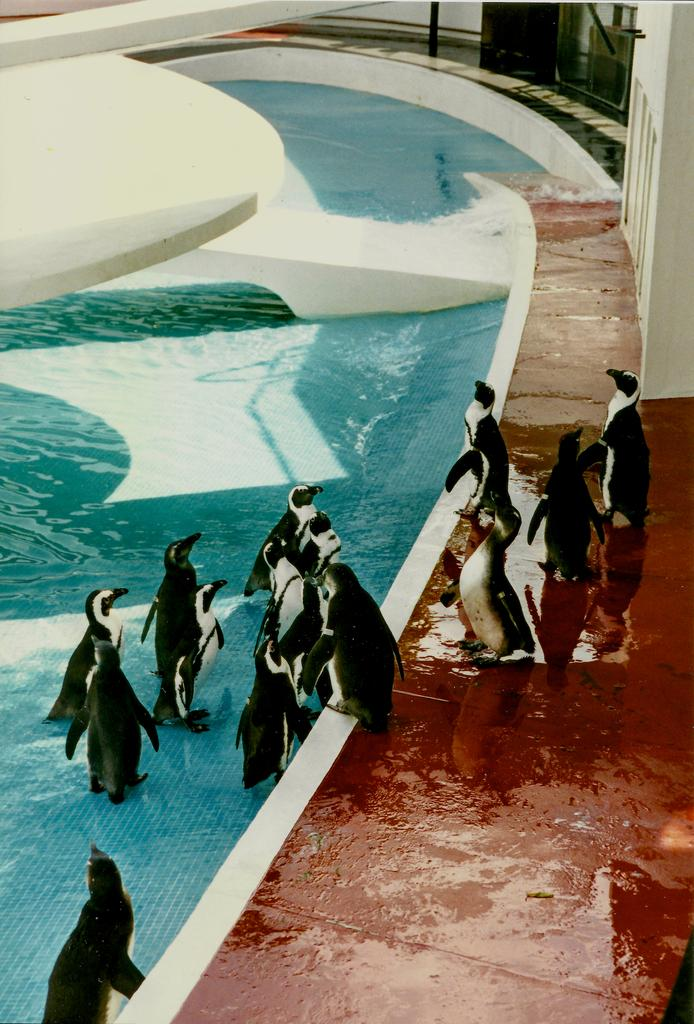What type of animals are present in the image? There are penguins in the image. Where are some of the penguins located? Some penguins are in a pool, while others are on a pavement. What riddle can be solved by the penguins in the image? There is no riddle present in the image, as it features penguins in different locations. What time of day is it in the image? The time of day cannot be determined from the image, as there are no clues or indications of the time. 